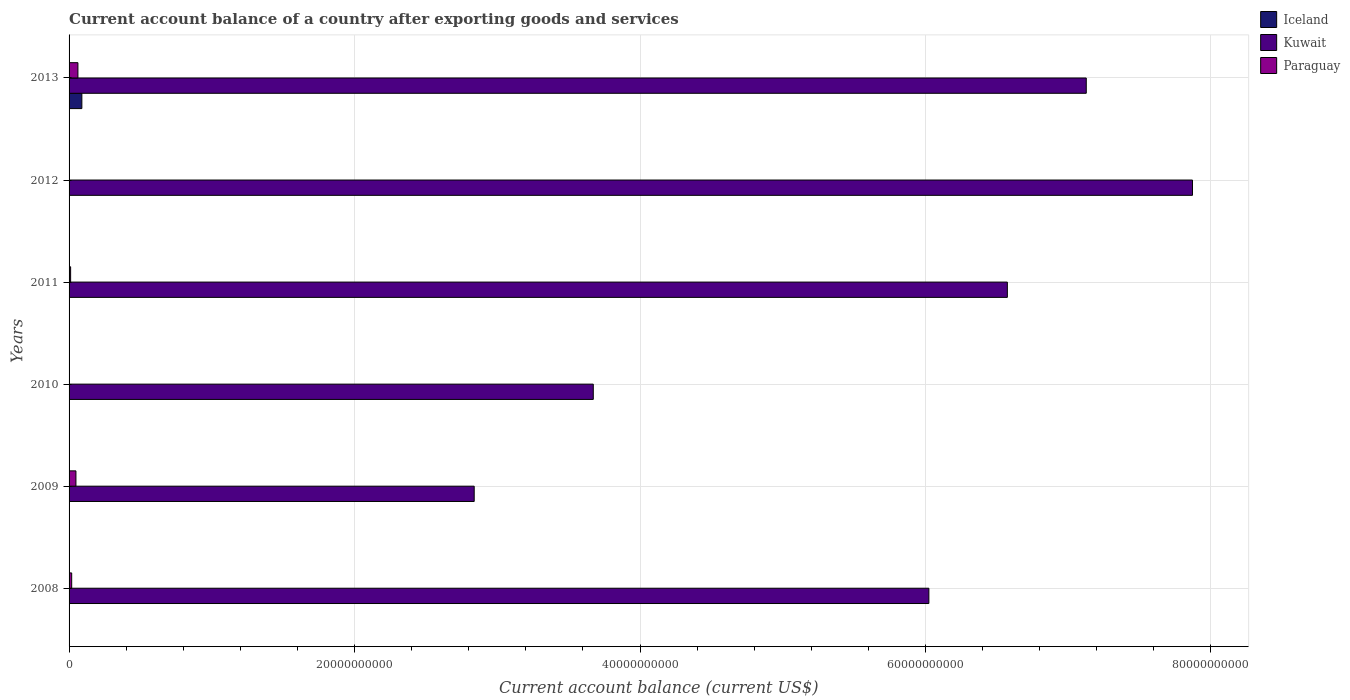How many different coloured bars are there?
Ensure brevity in your answer.  3. Are the number of bars per tick equal to the number of legend labels?
Ensure brevity in your answer.  No. Are the number of bars on each tick of the Y-axis equal?
Give a very brief answer. No. How many bars are there on the 3rd tick from the top?
Give a very brief answer. 2. How many bars are there on the 2nd tick from the bottom?
Ensure brevity in your answer.  2. What is the label of the 2nd group of bars from the top?
Provide a short and direct response. 2012. In how many cases, is the number of bars for a given year not equal to the number of legend labels?
Your answer should be very brief. 5. What is the account balance in Iceland in 2013?
Provide a short and direct response. 8.96e+08. Across all years, what is the maximum account balance in Iceland?
Ensure brevity in your answer.  8.96e+08. In which year was the account balance in Kuwait maximum?
Your answer should be compact. 2012. What is the total account balance in Iceland in the graph?
Offer a terse response. 8.96e+08. What is the difference between the account balance in Paraguay in 2009 and that in 2013?
Ensure brevity in your answer.  -1.39e+08. What is the difference between the account balance in Paraguay in 2011 and the account balance in Kuwait in 2012?
Your response must be concise. -7.86e+1. What is the average account balance in Kuwait per year?
Your answer should be compact. 5.68e+1. In the year 2009, what is the difference between the account balance in Paraguay and account balance in Kuwait?
Ensure brevity in your answer.  -2.79e+1. In how many years, is the account balance in Kuwait greater than 16000000000 US$?
Make the answer very short. 6. What is the ratio of the account balance in Kuwait in 2008 to that in 2009?
Your answer should be very brief. 2.12. Is the account balance in Paraguay in 2008 less than that in 2013?
Give a very brief answer. Yes. What is the difference between the highest and the second highest account balance in Kuwait?
Keep it short and to the point. 7.44e+09. What is the difference between the highest and the lowest account balance in Paraguay?
Offer a very short reply. 6.21e+08. In how many years, is the account balance in Paraguay greater than the average account balance in Paraguay taken over all years?
Give a very brief answer. 2. Is it the case that in every year, the sum of the account balance in Iceland and account balance in Kuwait is greater than the account balance in Paraguay?
Give a very brief answer. Yes. How many bars are there?
Ensure brevity in your answer.  11. Are all the bars in the graph horizontal?
Give a very brief answer. Yes. Does the graph contain any zero values?
Make the answer very short. Yes. Does the graph contain grids?
Provide a succinct answer. Yes. How are the legend labels stacked?
Your response must be concise. Vertical. What is the title of the graph?
Provide a short and direct response. Current account balance of a country after exporting goods and services. Does "Sub-Saharan Africa (all income levels)" appear as one of the legend labels in the graph?
Your answer should be compact. No. What is the label or title of the X-axis?
Your answer should be very brief. Current account balance (current US$). What is the label or title of the Y-axis?
Make the answer very short. Years. What is the Current account balance (current US$) in Iceland in 2008?
Provide a succinct answer. 0. What is the Current account balance (current US$) of Kuwait in 2008?
Provide a short and direct response. 6.02e+1. What is the Current account balance (current US$) in Paraguay in 2008?
Your answer should be very brief. 1.83e+08. What is the Current account balance (current US$) of Iceland in 2009?
Your response must be concise. 0. What is the Current account balance (current US$) of Kuwait in 2009?
Your answer should be very brief. 2.84e+1. What is the Current account balance (current US$) of Paraguay in 2009?
Provide a short and direct response. 4.82e+08. What is the Current account balance (current US$) in Kuwait in 2010?
Your answer should be compact. 3.67e+1. What is the Current account balance (current US$) of Kuwait in 2011?
Offer a very short reply. 6.57e+1. What is the Current account balance (current US$) of Paraguay in 2011?
Your response must be concise. 1.09e+08. What is the Current account balance (current US$) of Kuwait in 2012?
Your answer should be very brief. 7.87e+1. What is the Current account balance (current US$) of Iceland in 2013?
Offer a terse response. 8.96e+08. What is the Current account balance (current US$) in Kuwait in 2013?
Ensure brevity in your answer.  7.13e+1. What is the Current account balance (current US$) in Paraguay in 2013?
Offer a very short reply. 6.21e+08. Across all years, what is the maximum Current account balance (current US$) in Iceland?
Your answer should be compact. 8.96e+08. Across all years, what is the maximum Current account balance (current US$) in Kuwait?
Your answer should be very brief. 7.87e+1. Across all years, what is the maximum Current account balance (current US$) in Paraguay?
Offer a very short reply. 6.21e+08. Across all years, what is the minimum Current account balance (current US$) of Iceland?
Provide a succinct answer. 0. Across all years, what is the minimum Current account balance (current US$) in Kuwait?
Your answer should be compact. 2.84e+1. What is the total Current account balance (current US$) of Iceland in the graph?
Give a very brief answer. 8.96e+08. What is the total Current account balance (current US$) of Kuwait in the graph?
Your response must be concise. 3.41e+11. What is the total Current account balance (current US$) in Paraguay in the graph?
Your answer should be very brief. 1.39e+09. What is the difference between the Current account balance (current US$) in Kuwait in 2008 and that in 2009?
Provide a short and direct response. 3.19e+1. What is the difference between the Current account balance (current US$) in Paraguay in 2008 and that in 2009?
Provide a succinct answer. -2.98e+08. What is the difference between the Current account balance (current US$) in Kuwait in 2008 and that in 2010?
Provide a short and direct response. 2.35e+1. What is the difference between the Current account balance (current US$) of Kuwait in 2008 and that in 2011?
Provide a short and direct response. -5.50e+09. What is the difference between the Current account balance (current US$) of Paraguay in 2008 and that in 2011?
Ensure brevity in your answer.  7.42e+07. What is the difference between the Current account balance (current US$) of Kuwait in 2008 and that in 2012?
Your answer should be compact. -1.85e+1. What is the difference between the Current account balance (current US$) in Kuwait in 2008 and that in 2013?
Offer a terse response. -1.10e+1. What is the difference between the Current account balance (current US$) in Paraguay in 2008 and that in 2013?
Your response must be concise. -4.37e+08. What is the difference between the Current account balance (current US$) of Kuwait in 2009 and that in 2010?
Make the answer very short. -8.34e+09. What is the difference between the Current account balance (current US$) of Kuwait in 2009 and that in 2011?
Give a very brief answer. -3.74e+1. What is the difference between the Current account balance (current US$) in Paraguay in 2009 and that in 2011?
Ensure brevity in your answer.  3.73e+08. What is the difference between the Current account balance (current US$) of Kuwait in 2009 and that in 2012?
Your answer should be compact. -5.03e+1. What is the difference between the Current account balance (current US$) in Kuwait in 2009 and that in 2013?
Your answer should be compact. -4.29e+1. What is the difference between the Current account balance (current US$) of Paraguay in 2009 and that in 2013?
Your response must be concise. -1.39e+08. What is the difference between the Current account balance (current US$) in Kuwait in 2010 and that in 2011?
Offer a very short reply. -2.90e+1. What is the difference between the Current account balance (current US$) in Kuwait in 2010 and that in 2012?
Your answer should be compact. -4.20e+1. What is the difference between the Current account balance (current US$) of Kuwait in 2010 and that in 2013?
Provide a short and direct response. -3.45e+1. What is the difference between the Current account balance (current US$) of Kuwait in 2011 and that in 2012?
Make the answer very short. -1.30e+1. What is the difference between the Current account balance (current US$) of Kuwait in 2011 and that in 2013?
Give a very brief answer. -5.53e+09. What is the difference between the Current account balance (current US$) in Paraguay in 2011 and that in 2013?
Your response must be concise. -5.12e+08. What is the difference between the Current account balance (current US$) of Kuwait in 2012 and that in 2013?
Ensure brevity in your answer.  7.44e+09. What is the difference between the Current account balance (current US$) of Kuwait in 2008 and the Current account balance (current US$) of Paraguay in 2009?
Your answer should be compact. 5.98e+1. What is the difference between the Current account balance (current US$) of Kuwait in 2008 and the Current account balance (current US$) of Paraguay in 2011?
Provide a succinct answer. 6.01e+1. What is the difference between the Current account balance (current US$) of Kuwait in 2008 and the Current account balance (current US$) of Paraguay in 2013?
Your answer should be compact. 5.96e+1. What is the difference between the Current account balance (current US$) of Kuwait in 2009 and the Current account balance (current US$) of Paraguay in 2011?
Make the answer very short. 2.83e+1. What is the difference between the Current account balance (current US$) in Kuwait in 2009 and the Current account balance (current US$) in Paraguay in 2013?
Your answer should be very brief. 2.78e+1. What is the difference between the Current account balance (current US$) in Kuwait in 2010 and the Current account balance (current US$) in Paraguay in 2011?
Offer a terse response. 3.66e+1. What is the difference between the Current account balance (current US$) in Kuwait in 2010 and the Current account balance (current US$) in Paraguay in 2013?
Your response must be concise. 3.61e+1. What is the difference between the Current account balance (current US$) in Kuwait in 2011 and the Current account balance (current US$) in Paraguay in 2013?
Your response must be concise. 6.51e+1. What is the difference between the Current account balance (current US$) in Kuwait in 2012 and the Current account balance (current US$) in Paraguay in 2013?
Offer a terse response. 7.81e+1. What is the average Current account balance (current US$) of Iceland per year?
Give a very brief answer. 1.49e+08. What is the average Current account balance (current US$) in Kuwait per year?
Provide a succinct answer. 5.68e+1. What is the average Current account balance (current US$) in Paraguay per year?
Your response must be concise. 2.32e+08. In the year 2008, what is the difference between the Current account balance (current US$) in Kuwait and Current account balance (current US$) in Paraguay?
Your answer should be compact. 6.01e+1. In the year 2009, what is the difference between the Current account balance (current US$) of Kuwait and Current account balance (current US$) of Paraguay?
Provide a short and direct response. 2.79e+1. In the year 2011, what is the difference between the Current account balance (current US$) in Kuwait and Current account balance (current US$) in Paraguay?
Provide a short and direct response. 6.56e+1. In the year 2013, what is the difference between the Current account balance (current US$) in Iceland and Current account balance (current US$) in Kuwait?
Offer a terse response. -7.04e+1. In the year 2013, what is the difference between the Current account balance (current US$) of Iceland and Current account balance (current US$) of Paraguay?
Your answer should be compact. 2.75e+08. In the year 2013, what is the difference between the Current account balance (current US$) in Kuwait and Current account balance (current US$) in Paraguay?
Provide a short and direct response. 7.06e+1. What is the ratio of the Current account balance (current US$) of Kuwait in 2008 to that in 2009?
Keep it short and to the point. 2.12. What is the ratio of the Current account balance (current US$) in Paraguay in 2008 to that in 2009?
Offer a very short reply. 0.38. What is the ratio of the Current account balance (current US$) in Kuwait in 2008 to that in 2010?
Your answer should be compact. 1.64. What is the ratio of the Current account balance (current US$) of Kuwait in 2008 to that in 2011?
Keep it short and to the point. 0.92. What is the ratio of the Current account balance (current US$) in Paraguay in 2008 to that in 2011?
Your answer should be very brief. 1.68. What is the ratio of the Current account balance (current US$) in Kuwait in 2008 to that in 2012?
Your answer should be very brief. 0.77. What is the ratio of the Current account balance (current US$) of Kuwait in 2008 to that in 2013?
Offer a terse response. 0.85. What is the ratio of the Current account balance (current US$) in Paraguay in 2008 to that in 2013?
Your answer should be compact. 0.3. What is the ratio of the Current account balance (current US$) in Kuwait in 2009 to that in 2010?
Your answer should be compact. 0.77. What is the ratio of the Current account balance (current US$) of Kuwait in 2009 to that in 2011?
Your response must be concise. 0.43. What is the ratio of the Current account balance (current US$) in Paraguay in 2009 to that in 2011?
Provide a succinct answer. 4.42. What is the ratio of the Current account balance (current US$) of Kuwait in 2009 to that in 2012?
Provide a succinct answer. 0.36. What is the ratio of the Current account balance (current US$) in Kuwait in 2009 to that in 2013?
Give a very brief answer. 0.4. What is the ratio of the Current account balance (current US$) of Paraguay in 2009 to that in 2013?
Your answer should be very brief. 0.78. What is the ratio of the Current account balance (current US$) in Kuwait in 2010 to that in 2011?
Offer a terse response. 0.56. What is the ratio of the Current account balance (current US$) of Kuwait in 2010 to that in 2012?
Provide a short and direct response. 0.47. What is the ratio of the Current account balance (current US$) in Kuwait in 2010 to that in 2013?
Provide a short and direct response. 0.52. What is the ratio of the Current account balance (current US$) in Kuwait in 2011 to that in 2012?
Offer a terse response. 0.84. What is the ratio of the Current account balance (current US$) of Kuwait in 2011 to that in 2013?
Offer a very short reply. 0.92. What is the ratio of the Current account balance (current US$) in Paraguay in 2011 to that in 2013?
Provide a succinct answer. 0.18. What is the ratio of the Current account balance (current US$) in Kuwait in 2012 to that in 2013?
Offer a very short reply. 1.1. What is the difference between the highest and the second highest Current account balance (current US$) of Kuwait?
Provide a succinct answer. 7.44e+09. What is the difference between the highest and the second highest Current account balance (current US$) in Paraguay?
Keep it short and to the point. 1.39e+08. What is the difference between the highest and the lowest Current account balance (current US$) of Iceland?
Provide a short and direct response. 8.96e+08. What is the difference between the highest and the lowest Current account balance (current US$) of Kuwait?
Make the answer very short. 5.03e+1. What is the difference between the highest and the lowest Current account balance (current US$) in Paraguay?
Provide a short and direct response. 6.21e+08. 